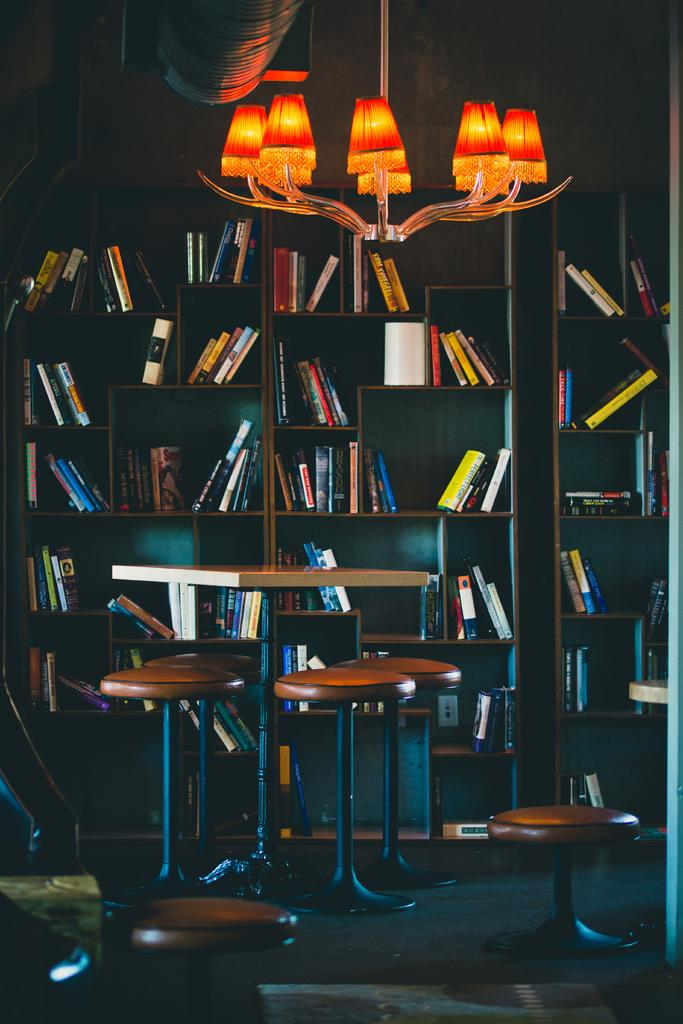What type of furniture is present in the image? There are chairs and tables in the image. What is attached to the roof above the chairs and tables? There is a jhoomar attached to the roof above the chairs and tables. What can be seen in the background of the image? There is a bookshelf in the background of the image. How many sons are visible in the image? There are no sons present in the image. What type of vase can be seen on the bookshelf in the image? There is no vase present on the bookshelf in the image. 